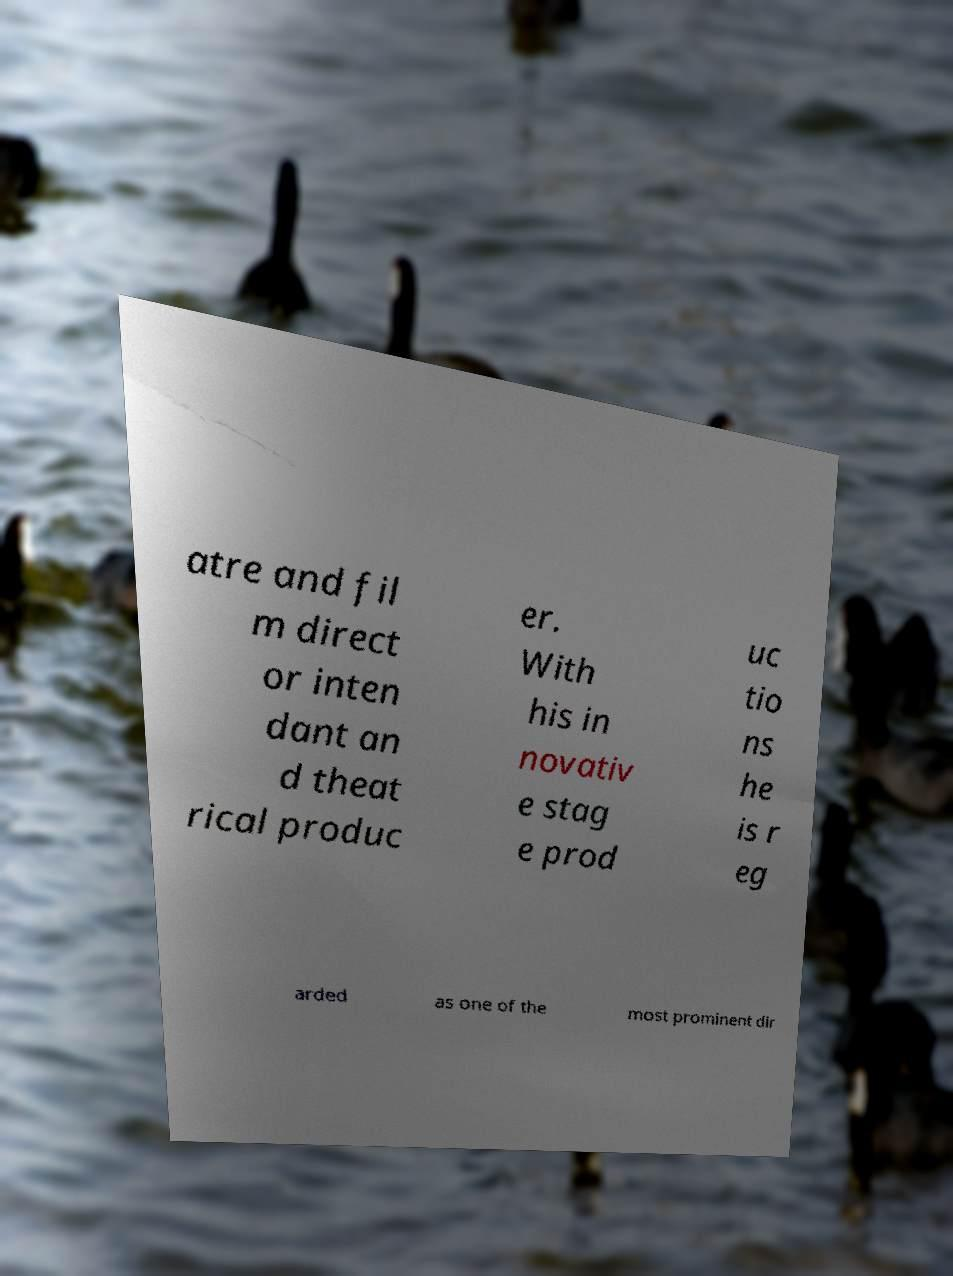Could you assist in decoding the text presented in this image and type it out clearly? atre and fil m direct or inten dant an d theat rical produc er. With his in novativ e stag e prod uc tio ns he is r eg arded as one of the most prominent dir 